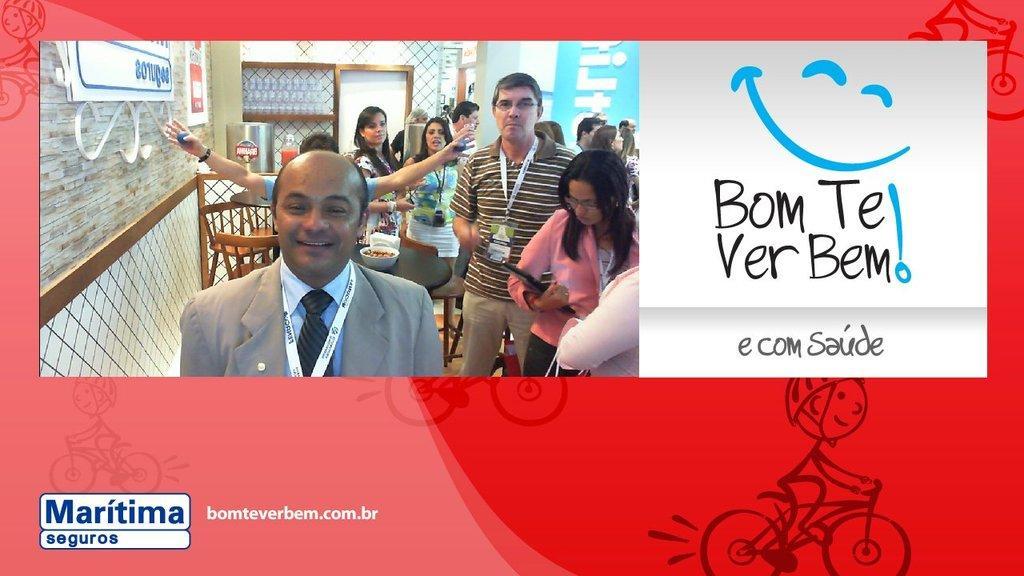In one or two sentences, can you explain what this image depicts? In this image we can see an advertisement. There is a picture. We can see people. On the left there is a wall and we can see chairs and tables. In the background there is a wall. We can see text. 